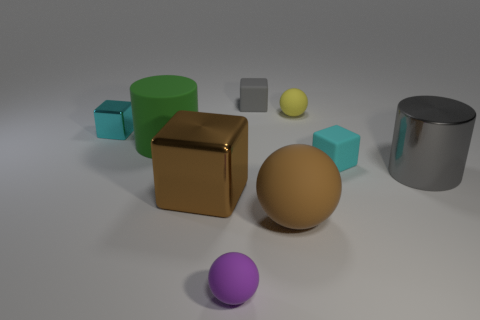Subtract all gray blocks. How many blocks are left? 3 Subtract all brown rubber balls. How many balls are left? 2 Subtract all red blocks. Subtract all green spheres. How many blocks are left? 4 Subtract all blocks. How many objects are left? 5 Subtract all green shiny blocks. Subtract all brown objects. How many objects are left? 7 Add 4 big gray cylinders. How many big gray cylinders are left? 5 Add 9 green matte cylinders. How many green matte cylinders exist? 10 Subtract 0 cyan spheres. How many objects are left? 9 